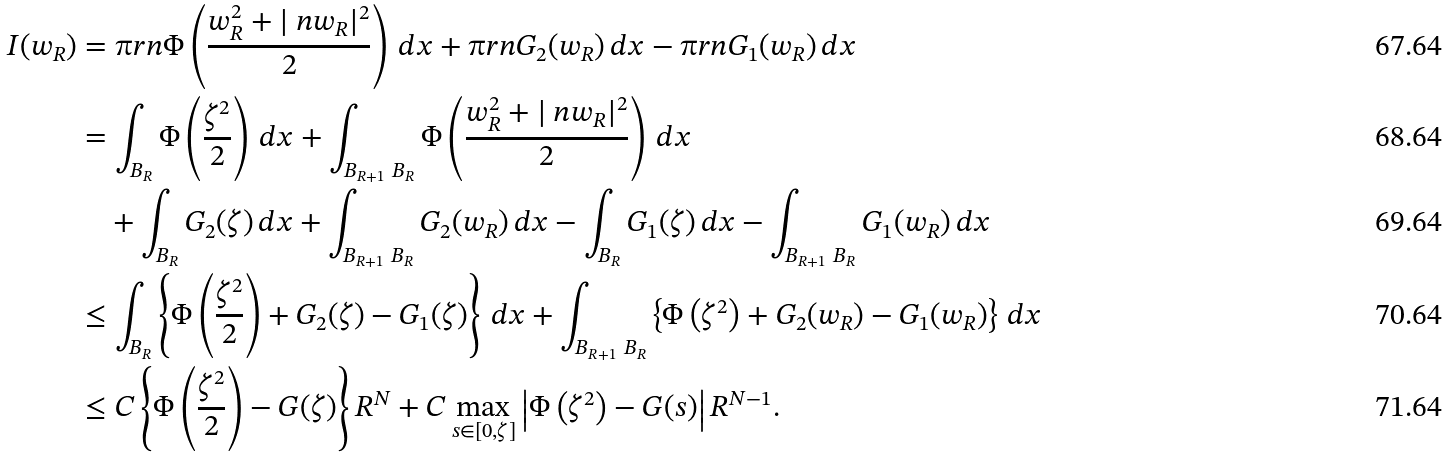Convert formula to latex. <formula><loc_0><loc_0><loc_500><loc_500>I ( w _ { R } ) & = \i r n \Phi \left ( \frac { w _ { R } ^ { 2 } + | \ n w _ { R } | ^ { 2 } } 2 \right ) \, d x + \i r n G _ { 2 } ( w _ { R } ) \, d x - \i r n G _ { 1 } ( w _ { R } ) \, d x \\ & = \int _ { B _ { R } } \Phi \left ( \frac { \zeta ^ { 2 } } 2 \right ) \, d x + \int _ { B _ { R + 1 } \ B _ { R } } \Phi \left ( \frac { w _ { R } ^ { 2 } + | \ n w _ { R } | ^ { 2 } } 2 \right ) \, d x \\ & \quad + \int _ { B _ { R } } G _ { 2 } ( \zeta ) \, d x + \int _ { B _ { R + 1 } \ B _ { R } } G _ { 2 } ( w _ { R } ) \, d x - \int _ { B _ { R } } G _ { 1 } ( \zeta ) \, d x - \int _ { B _ { R + 1 } \ B _ { R } } G _ { 1 } ( w _ { R } ) \, d x \\ & \leq \int _ { B _ { R } } \left \{ \Phi \left ( \frac { \zeta ^ { 2 } } 2 \right ) + G _ { 2 } ( \zeta ) - G _ { 1 } ( \zeta ) \right \} \, d x + \int _ { B _ { R + 1 } \ B _ { R } } \left \{ \Phi \left ( \zeta ^ { 2 } \right ) + G _ { 2 } ( w _ { R } ) - G _ { 1 } ( w _ { R } ) \right \} \, d x \\ & \leq C \left \{ \Phi \left ( \frac { \zeta ^ { 2 } } 2 \right ) - G ( \zeta ) \right \} R ^ { N } + C \max _ { s \in [ 0 , \zeta ] } \left | \Phi \left ( \zeta ^ { 2 } \right ) - G ( s ) \right | R ^ { N - 1 } .</formula> 